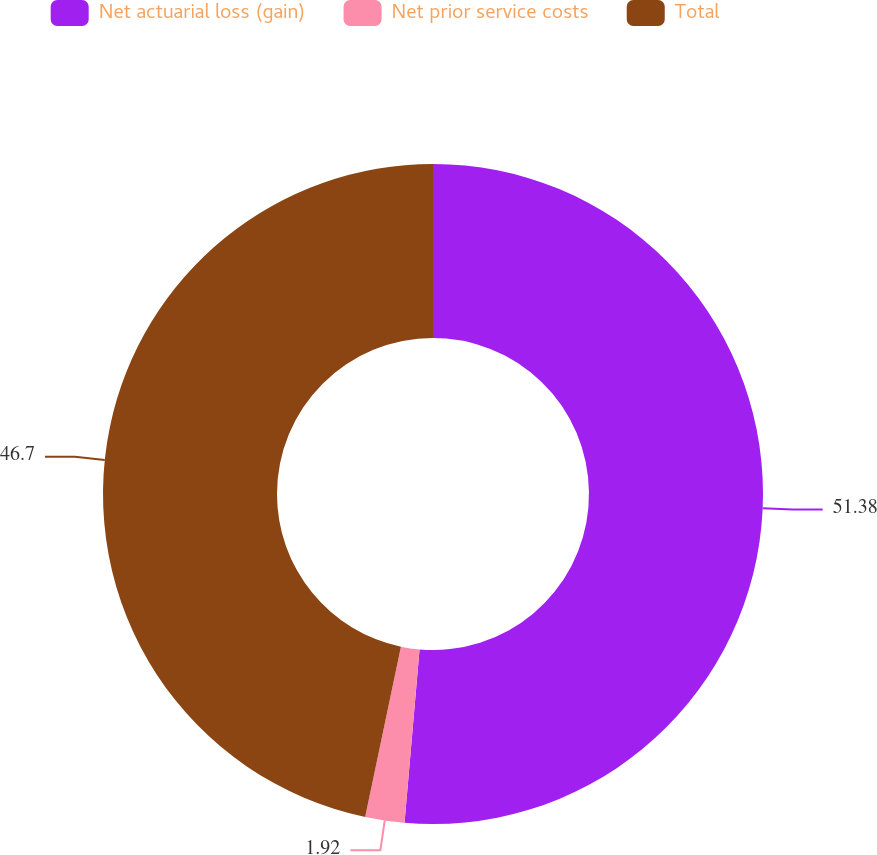<chart> <loc_0><loc_0><loc_500><loc_500><pie_chart><fcel>Net actuarial loss (gain)<fcel>Net prior service costs<fcel>Total<nl><fcel>51.37%<fcel>1.92%<fcel>46.7%<nl></chart> 